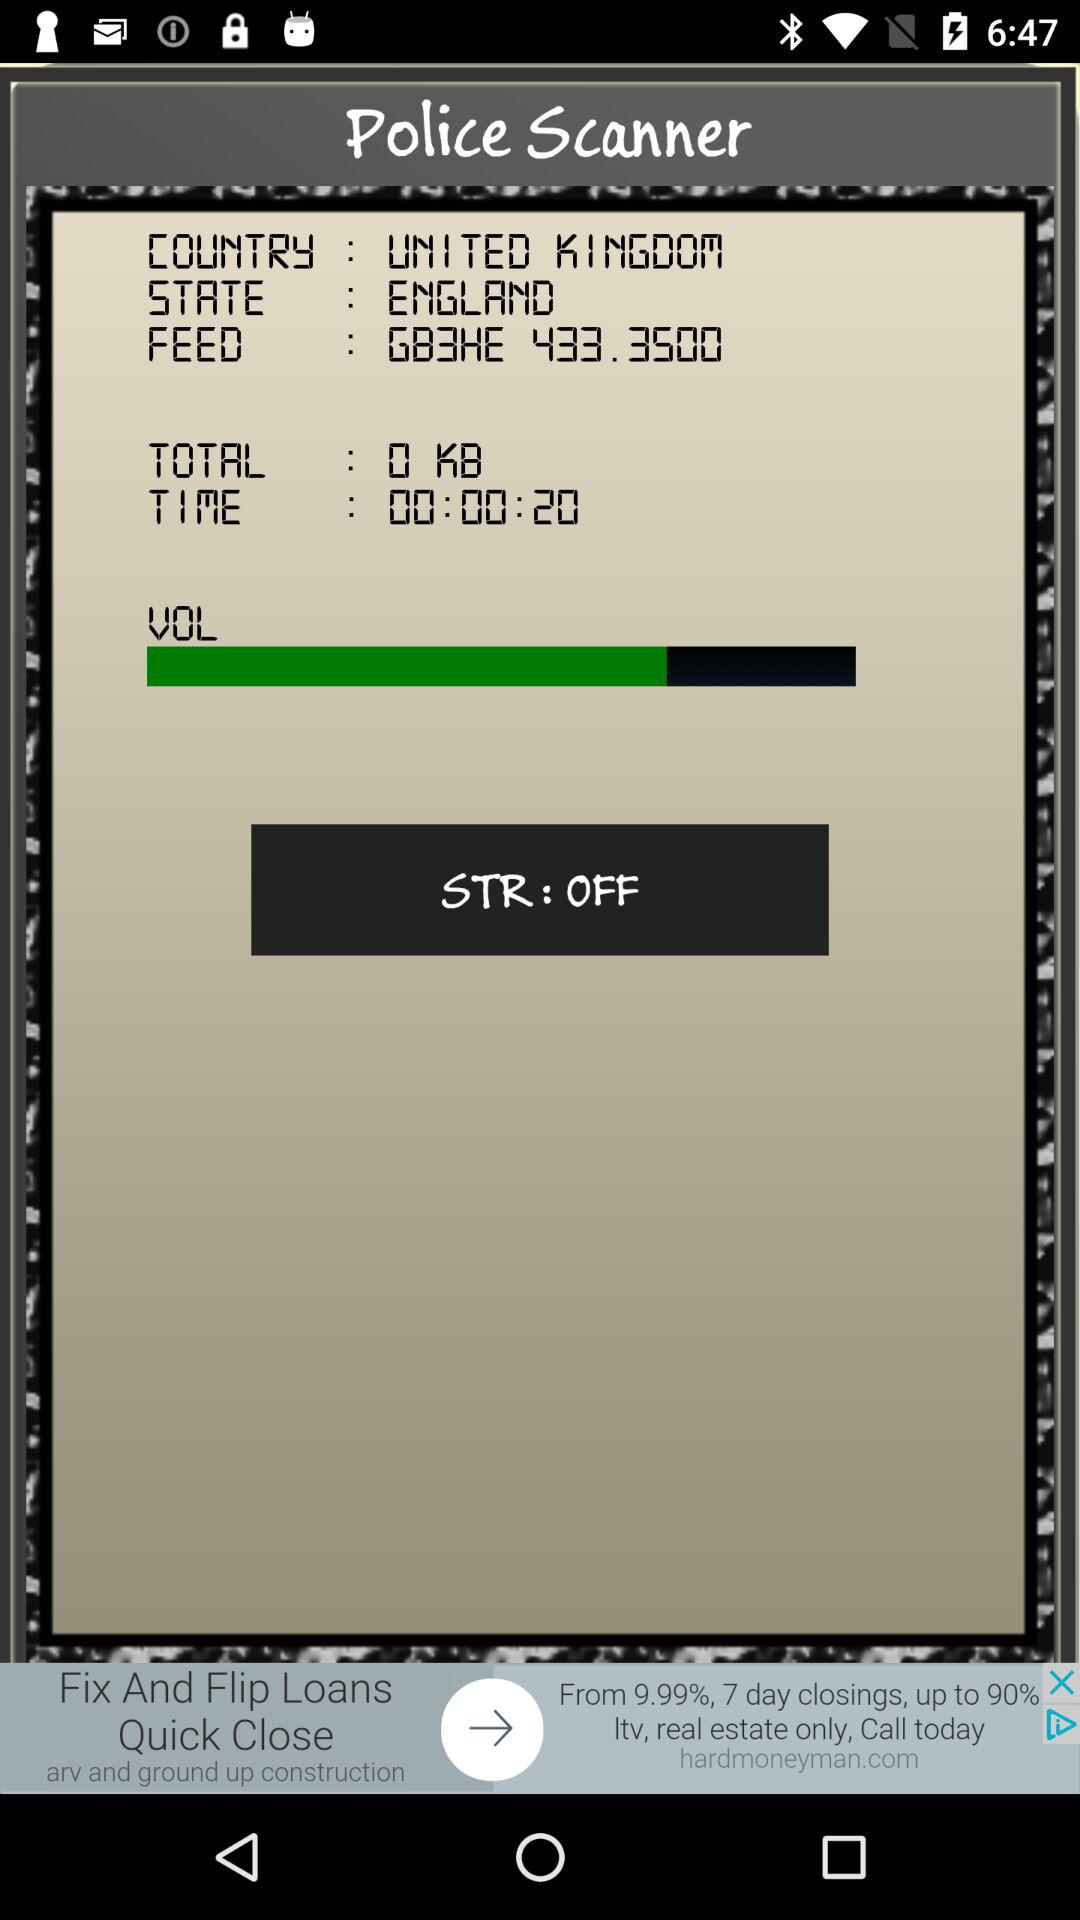How many seconds are in the total time?
Answer the question using a single word or phrase. 20 